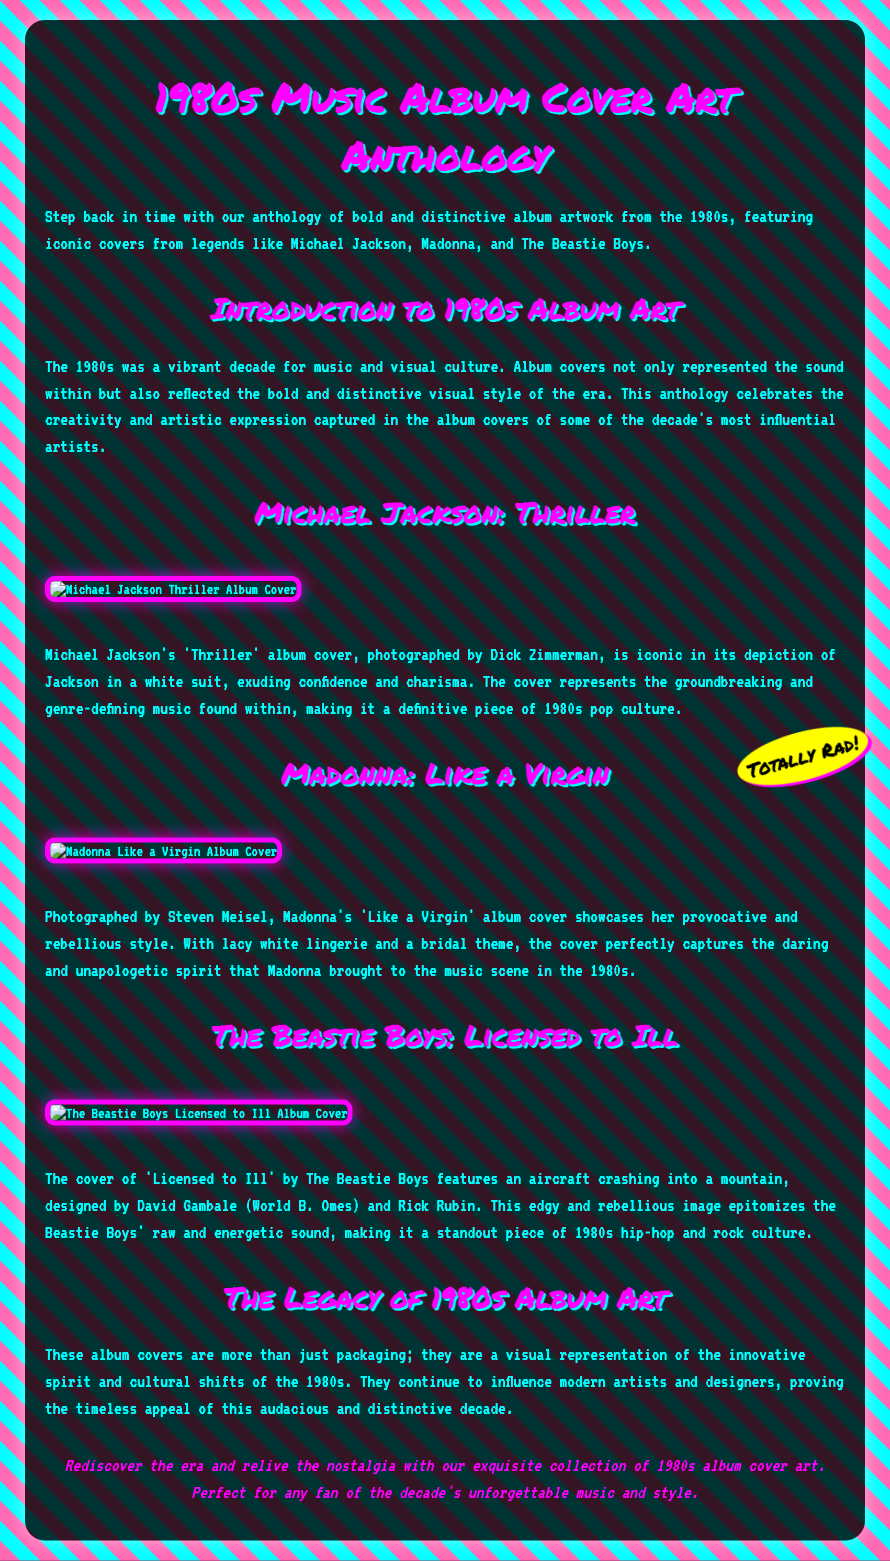What is the title of the anthology? The title of the anthology is specified at the top of the document.
Answer: 1980s Music Album Cover Art Anthology Who is the photographer of Michael Jackson's 'Thriller' album cover? The photographer for the 'Thriller' album cover is mentioned in the text describing it.
Answer: Dick Zimmerman What iconic album cover features Madonna in lacy white lingerie? The document highlights an album cover showcasing Madonna's provocative style.
Answer: Like a Virgin Which band is associated with the album 'Licensed to Ill'? The document directly links the album 'Licensed to Ill' to a specific band.
Answer: The Beastie Boys What color is the background of the document? The background color is described at the beginning of the document.
Answer: Pink What theme does Madonna's 'Like a Virgin' album cover represent? The description of Madonna's album cover provides insight into its thematic representation.
Answer: Bridal What visual element is featured on The Beastie Boys' 'Licensed to Ill' cover? The text specifies a prominent image depicted on the cover of this album.
Answer: Aircraft crashing In which decade is the artwork being celebrated? The document intentionally focuses on a specific decade in its theme.
Answer: 1980s What represents the innovative spirit of the 1980s in the document? The document refers to the significance of album covers in representing cultural shifts.
Answer: Album covers 